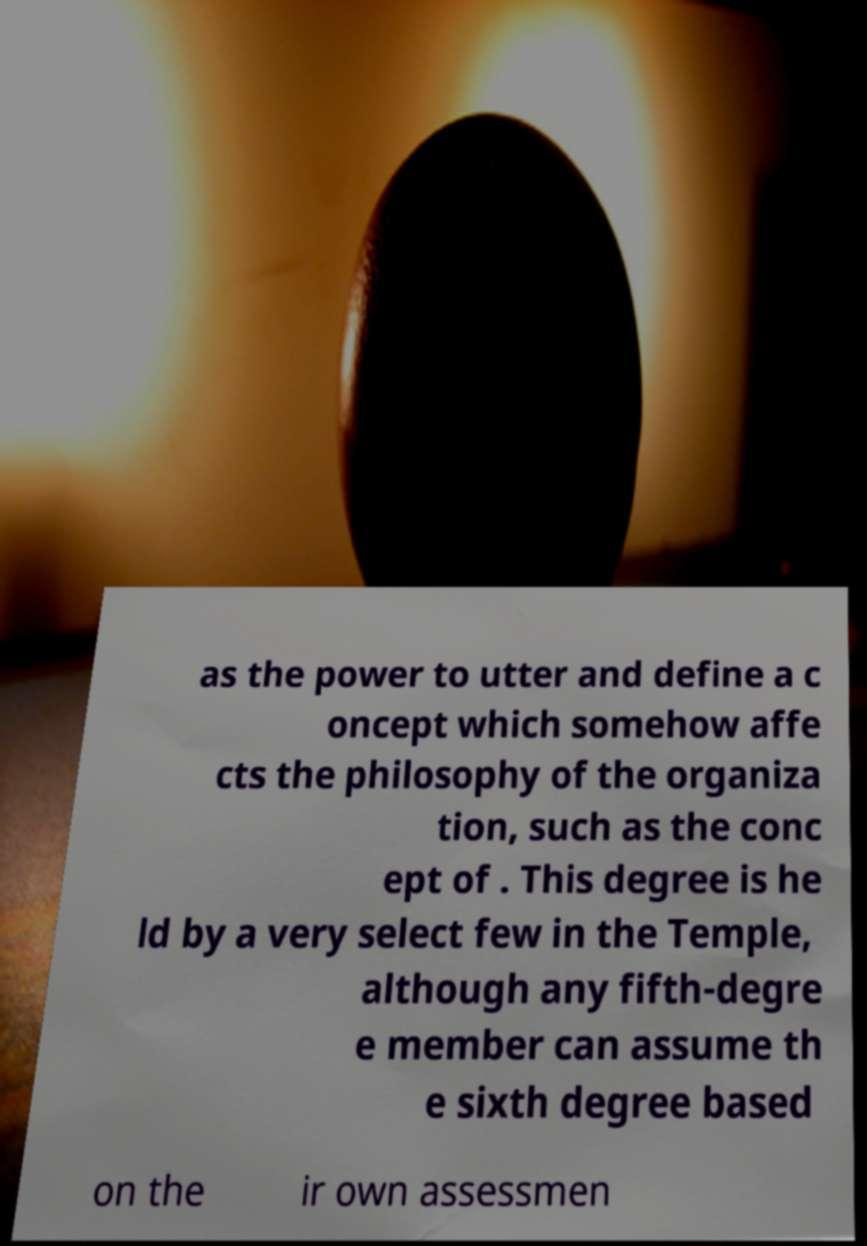There's text embedded in this image that I need extracted. Can you transcribe it verbatim? as the power to utter and define a c oncept which somehow affe cts the philosophy of the organiza tion, such as the conc ept of . This degree is he ld by a very select few in the Temple, although any fifth-degre e member can assume th e sixth degree based on the ir own assessmen 